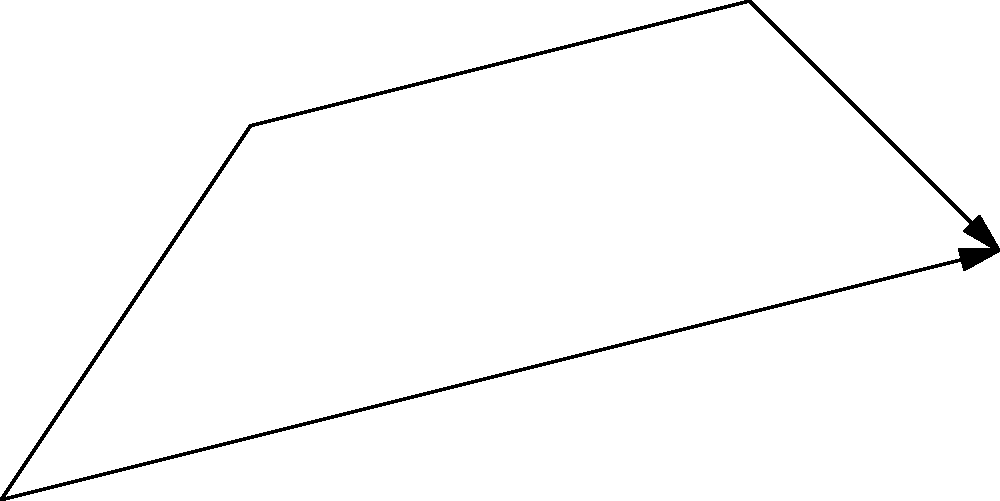In an online information network, nodes represent different social media platforms, and edges represent the flow of information between them. The weights on the edges indicate the time (in minutes) it takes for information to propagate from one platform to another. As a social activist concerned with the rapid spread of accurate information about women's rights, what is the shortest time (in minutes) required for information to travel from $v_1$ to $v_5$? To find the shortest path from $v_1$ to $v_5$, we need to consider all possible paths and their total weights:

1. Path 1: $v_1 \rightarrow v_2 \rightarrow v_4 \rightarrow v_5$
   Total time = $5 + 4 + 3 = 12$ minutes

2. Path 2: $v_1 \rightarrow v_3 \rightarrow v_5$
   Total time = $3 + 6 = 9$ minutes

The shortest path is the one with the smallest total weight. In this case, Path 2 ($v_1 \rightarrow v_3 \rightarrow v_5$) has a total time of 9 minutes, which is less than Path 1's 12 minutes.

Therefore, the shortest time required for information to travel from $v_1$ to $v_5$ is 9 minutes.

This result is crucial for a social activist focused on rapidly spreading accurate information about women's rights across different online platforms, as it identifies the most efficient route for information dissemination.
Answer: 9 minutes 